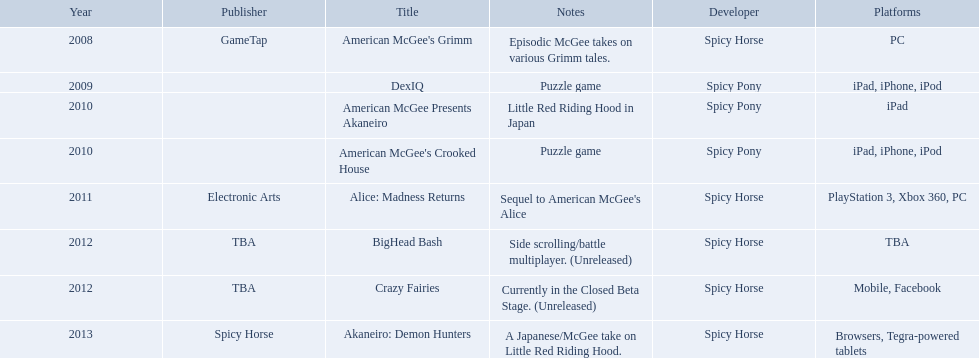What are all of the game titles? American McGee's Grimm, DexIQ, American McGee Presents Akaneiro, American McGee's Crooked House, Alice: Madness Returns, BigHead Bash, Crazy Fairies, Akaneiro: Demon Hunters. Which developer developed a game in 2011? Spicy Horse. Who published this game in 2011 Electronic Arts. What was the name of this published game in 2011? Alice: Madness Returns. 